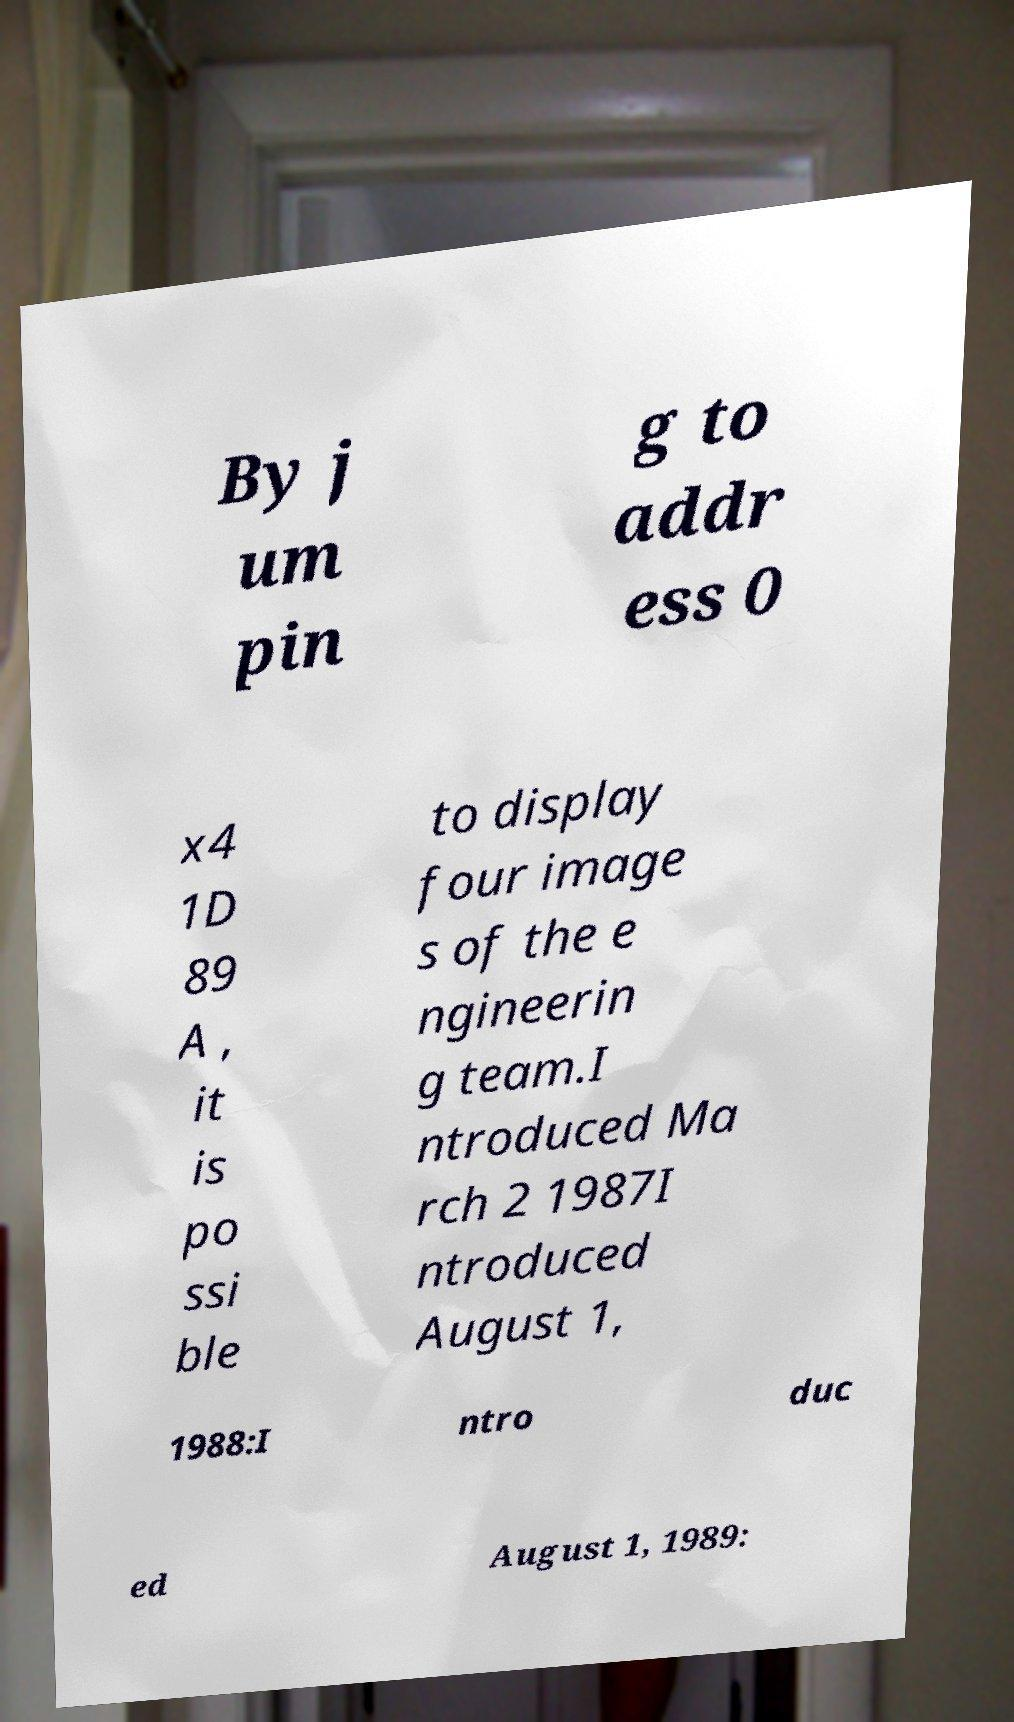For documentation purposes, I need the text within this image transcribed. Could you provide that? By j um pin g to addr ess 0 x4 1D 89 A , it is po ssi ble to display four image s of the e ngineerin g team.I ntroduced Ma rch 2 1987I ntroduced August 1, 1988:I ntro duc ed August 1, 1989: 